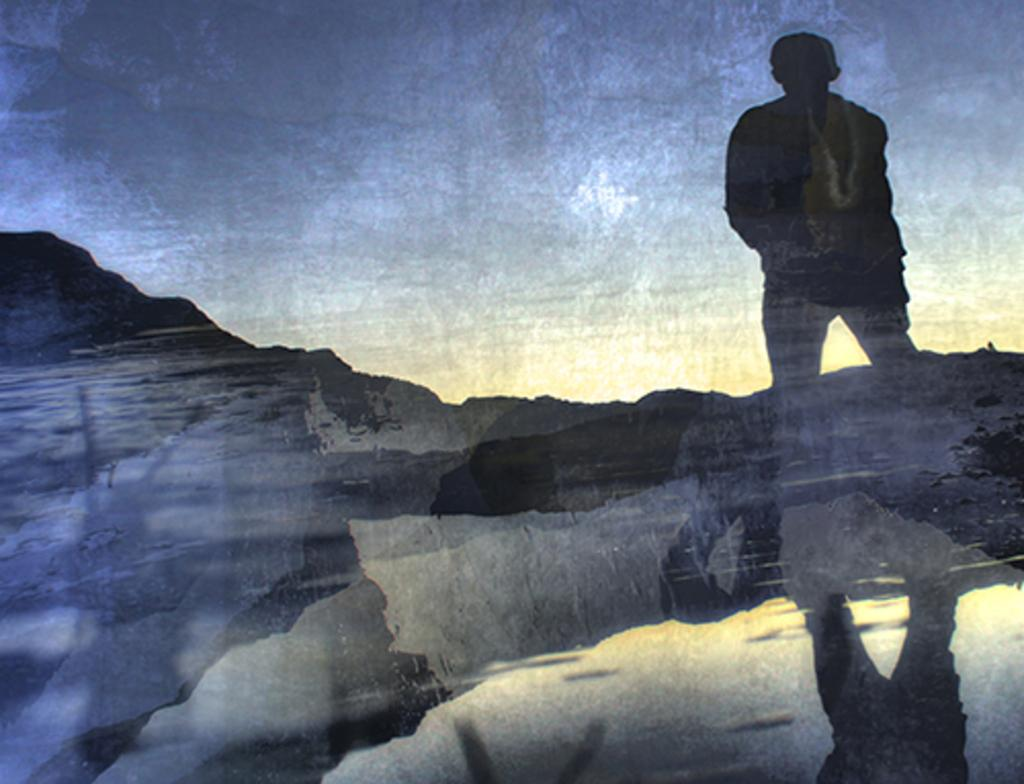Who or what is present in the image? There is a person in the image. Where is the person located? The person is standing on a mountain. Can you describe any additional features of the image? There is a reflection of the person in the image. What type of plastic is used to make the yoke in the image? There is no yoke present in the image, so it is not possible to determine what type of plastic might be used. 